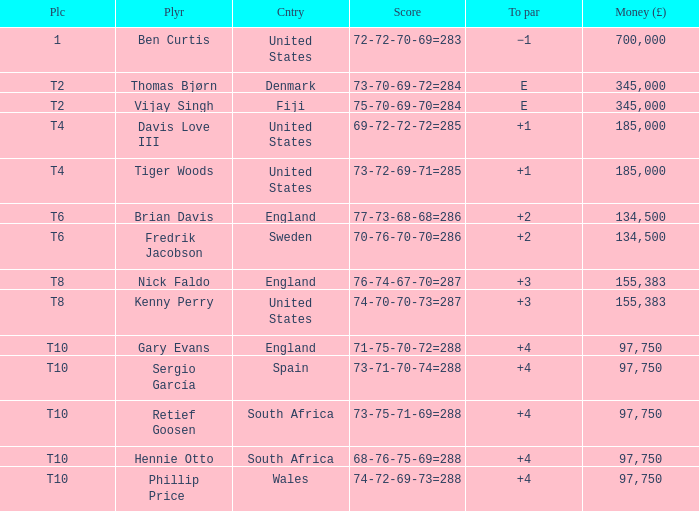What is the To Par of Fredrik Jacobson? 2.0. 